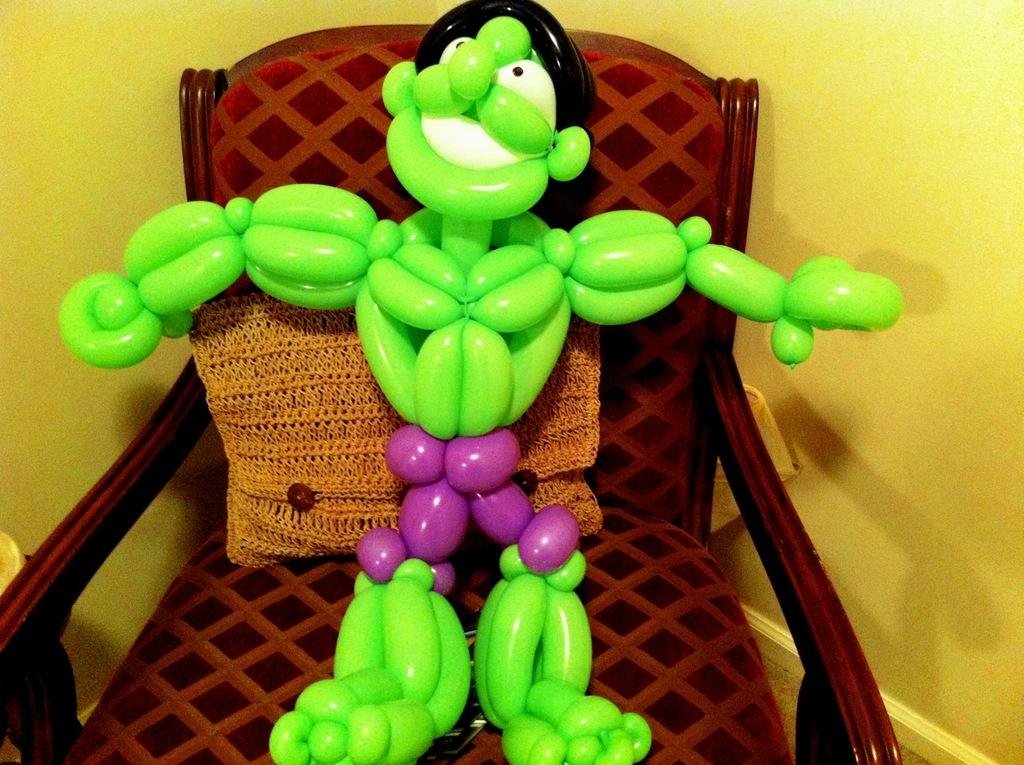What type of toy is present in the image? There is a toy made with balloons in the image. What colors are the balloons in the toy? The balloons are in green, white, and black colors. Where is the toy located in the image? The toy is on a chair. What color is the background wall in the image? The background wall is yellow. How many quarters can be seen in the image? There are no quarters present in the image. What type of attraction is depicted in the image? There is no attraction depicted in the image; it features a toy made with balloons on a chair. 